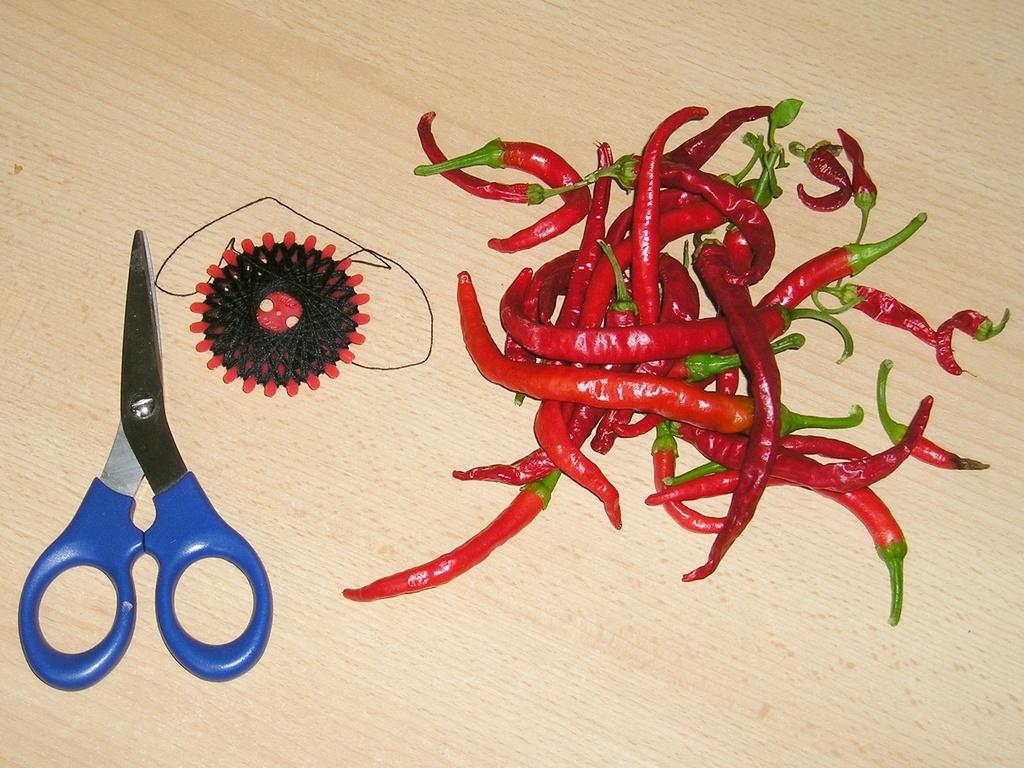What type of tool is visible in the image? There is a scissor in the image. Can you describe the color and design of the object next to the scissor? There is a black and red object in the image. What is being used with the scissor in the image? There is thread in the image. What type of food is present in the image? There are red chilies with stems in the image. What is the surface made of that the objects are placed on? The objects are on a wooden surface. What type of grape is being used to fix the error in the image? There is no grape present in the image, nor is there any indication of an error. 